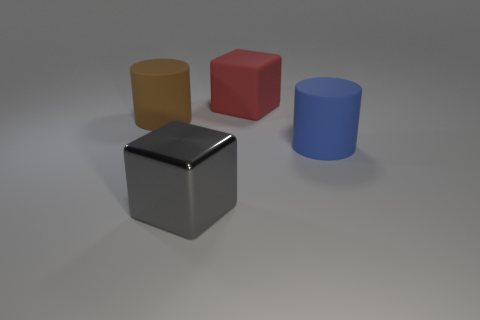Add 4 blue cylinders. How many objects exist? 8 Subtract 0 purple cubes. How many objects are left? 4 Subtract all balls. Subtract all big rubber cylinders. How many objects are left? 2 Add 1 cubes. How many cubes are left? 3 Add 3 brown cylinders. How many brown cylinders exist? 4 